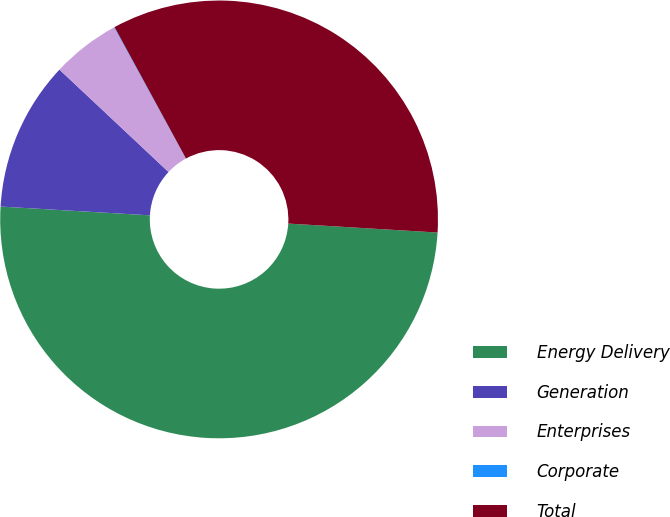Convert chart to OTSL. <chart><loc_0><loc_0><loc_500><loc_500><pie_chart><fcel>Energy Delivery<fcel>Generation<fcel>Enterprises<fcel>Corporate<fcel>Total<nl><fcel>49.98%<fcel>11.06%<fcel>5.04%<fcel>0.04%<fcel>33.88%<nl></chart> 